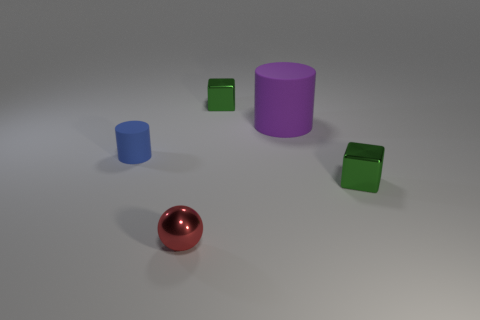Add 3 red metallic objects. How many objects exist? 8 Subtract all spheres. How many objects are left? 4 Subtract 0 yellow blocks. How many objects are left? 5 Subtract all small blue things. Subtract all blue rubber objects. How many objects are left? 3 Add 4 rubber things. How many rubber things are left? 6 Add 3 big blue rubber blocks. How many big blue rubber blocks exist? 3 